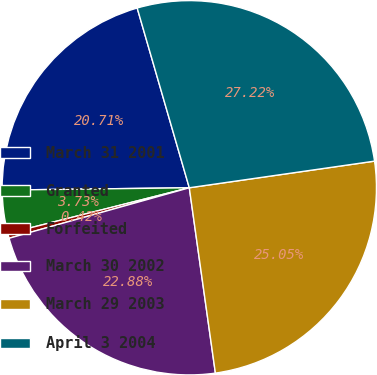<chart> <loc_0><loc_0><loc_500><loc_500><pie_chart><fcel>March 31 2001<fcel>Granted<fcel>Forfeited<fcel>March 30 2002<fcel>March 29 2003<fcel>April 3 2004<nl><fcel>20.71%<fcel>3.73%<fcel>0.42%<fcel>22.88%<fcel>25.05%<fcel>27.22%<nl></chart> 